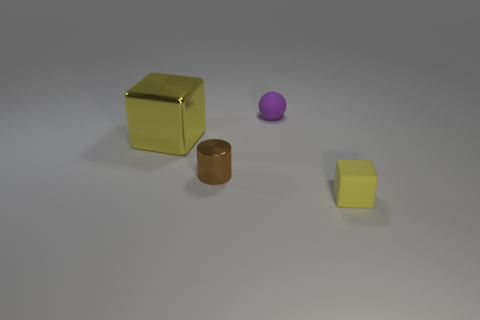Does the large object have the same material as the brown thing?
Give a very brief answer. Yes. What shape is the purple thing that is the same size as the cylinder?
Keep it short and to the point. Sphere. Are there more large gray metallic objects than tiny blocks?
Your answer should be very brief. No. There is a thing that is both in front of the small purple ball and behind the brown cylinder; what is its material?
Provide a succinct answer. Metal. How many other objects are there of the same material as the large yellow object?
Keep it short and to the point. 1. How many matte spheres have the same color as the rubber block?
Ensure brevity in your answer.  0. What size is the matte thing that is in front of the object behind the yellow thing that is to the left of the rubber cube?
Give a very brief answer. Small. What number of matte objects are either tiny things or blocks?
Provide a succinct answer. 2. Does the purple rubber object have the same shape as the matte object that is in front of the small purple thing?
Make the answer very short. No. Are there more purple objects behind the big yellow cube than metallic things in front of the tiny brown thing?
Offer a terse response. Yes. 